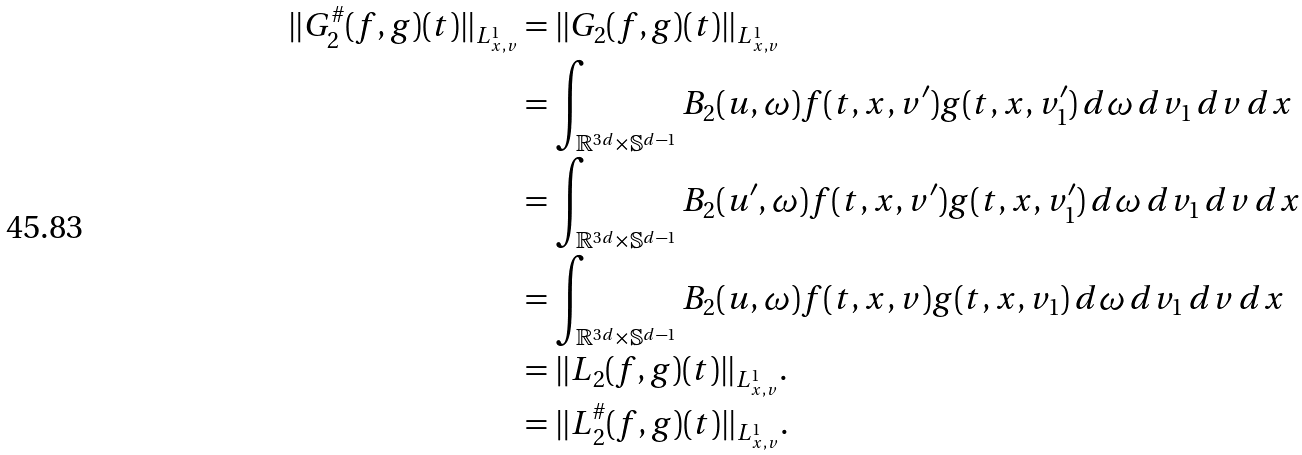<formula> <loc_0><loc_0><loc_500><loc_500>\| G _ { 2 } ^ { \# } ( f , g ) ( t ) \| _ { L ^ { 1 } _ { x , v } } & = \| G _ { 2 } ( f , g ) ( t ) \| _ { L ^ { 1 } _ { x , v } } \\ & = \int _ { \mathbb { R } ^ { 3 d } \times \mathbb { S } ^ { d - 1 } } B _ { 2 } ( u , \omega ) f ( t , x , v ^ { \prime } ) g ( t , x , v _ { 1 } ^ { \prime } ) \, d \omega \, d v _ { 1 } \, d v \, d x \\ & = \int _ { \mathbb { R } ^ { 3 d } \times \mathbb { S } ^ { d - 1 } } B _ { 2 } ( u ^ { \prime } , \omega ) f ( t , x , v ^ { \prime } ) g ( t , x , v _ { 1 } ^ { \prime } ) \, d \omega \, d v _ { 1 } \, d v \, d x \\ & = \int _ { \mathbb { R } ^ { 3 d } \times \mathbb { S } ^ { d - 1 } } B _ { 2 } ( u , \omega ) f ( t , x , v ) g ( t , x , v _ { 1 } ) \, d \omega \, d v _ { 1 } \, d v \, d x \\ & = \| L _ { 2 } ( f , g ) ( t ) \| _ { L ^ { 1 } _ { x , v } } . \\ & = \| L _ { 2 } ^ { \# } ( f , g ) ( t ) \| _ { L ^ { 1 } _ { x , v } } .</formula> 